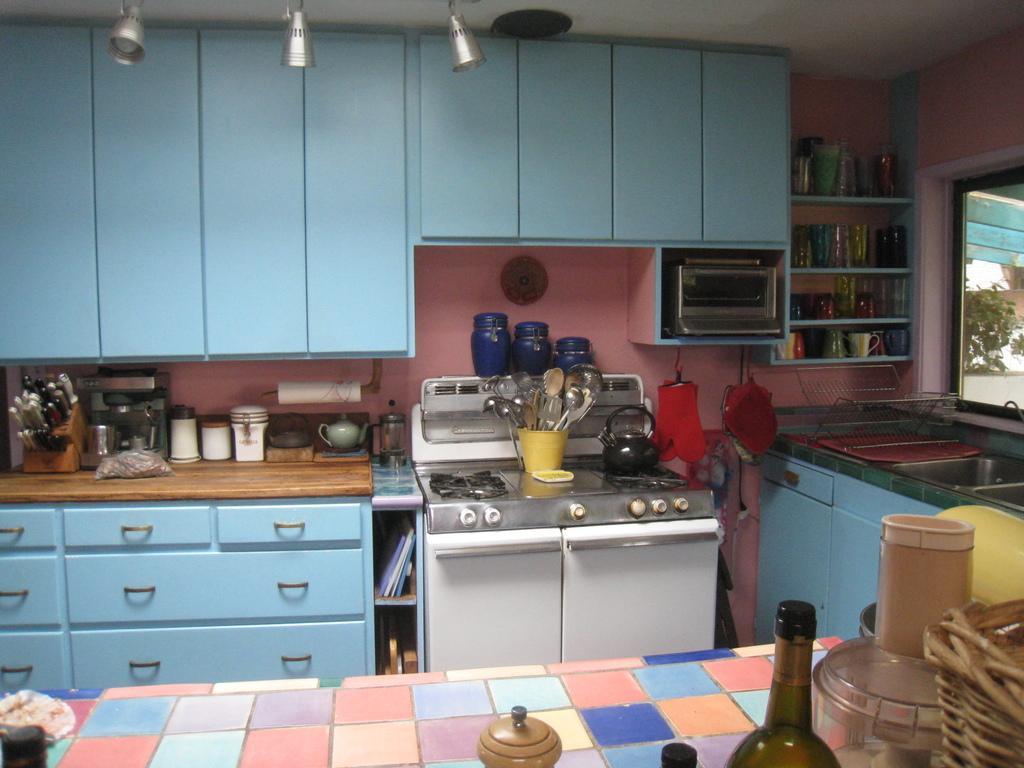Can you describe this image briefly? This is a picture of the kitchen. In the foreground of the picture there are bottle, mixer, basket and other objects. In the center of the picture there are spatulas, knives, jar, closet, sink, cups, glasses and many kitchen utensils. At the top there are lights. On the right there is a window, outside the window there is a plant and wall. 